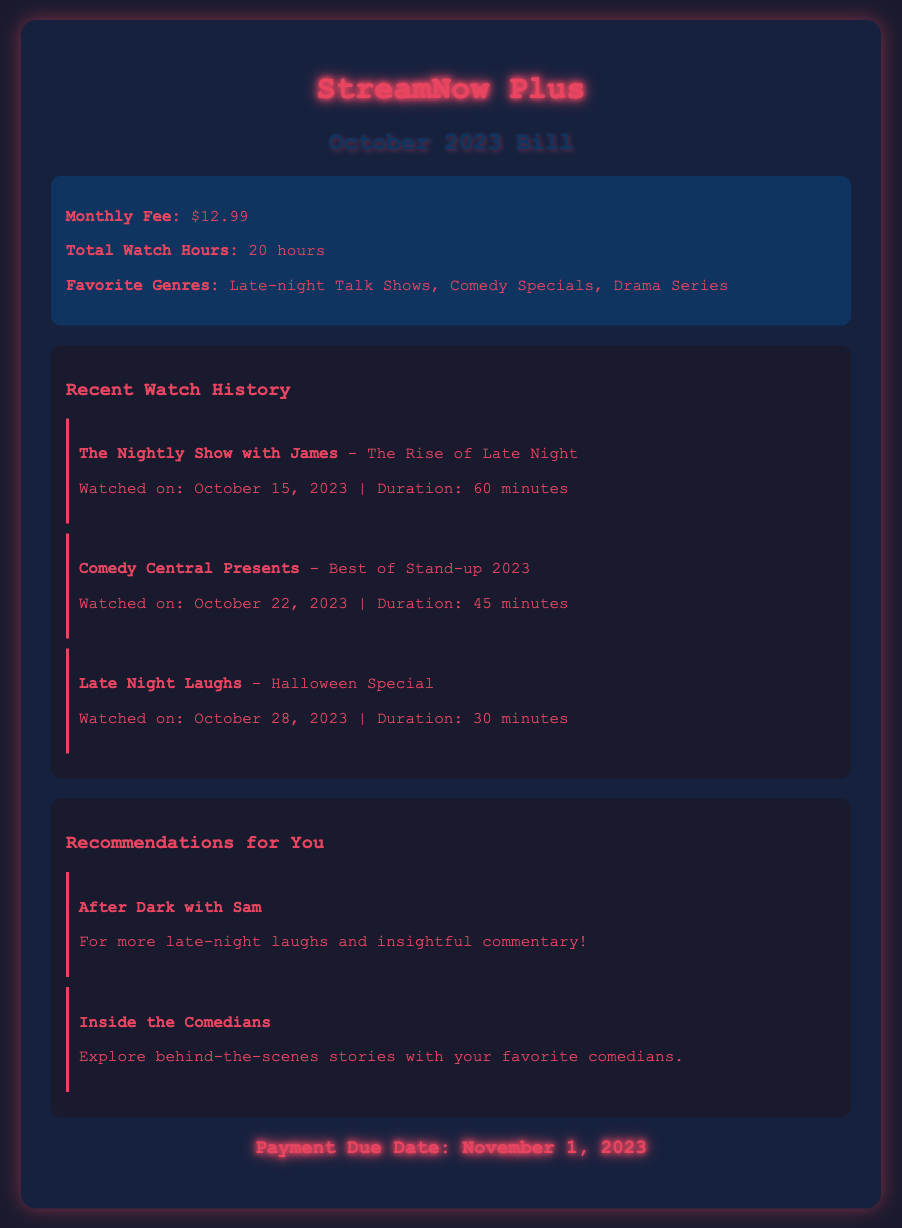What is the monthly fee? The monthly fee is stated in the document under the highlight section.
Answer: $12.99 How many hours were watched in total? The total watch hours are provided in the highlight section of the document.
Answer: 20 hours What was the last show watched? The last show listed in the recent watch history is the most recent entry.
Answer: Late Night Laughs - Halloween Special When is the payment due? The payment due date is mentioned in the payment information section of the document.
Answer: November 1, 2023 What genre is listed as a favorite? The favorite genres are highlighted in the document under the highlight section.
Answer: Late-night Talk Shows Which show is recommended for more late-night laughs? The recommendations section provides a suggestion for a show that fits this description.
Answer: After Dark with Sam How long was "The Nightly Show with James"? The duration of this specific show can be found in the watch history section.
Answer: 60 minutes How many shows were watched in October? The number of individual shows listed in recent watch history reflects this total.
Answer: 3 shows 